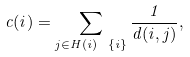<formula> <loc_0><loc_0><loc_500><loc_500>c ( i ) = \sum _ { j \in H ( i ) \ \{ i \} } \frac { 1 } { d ( i , j ) } ,</formula> 